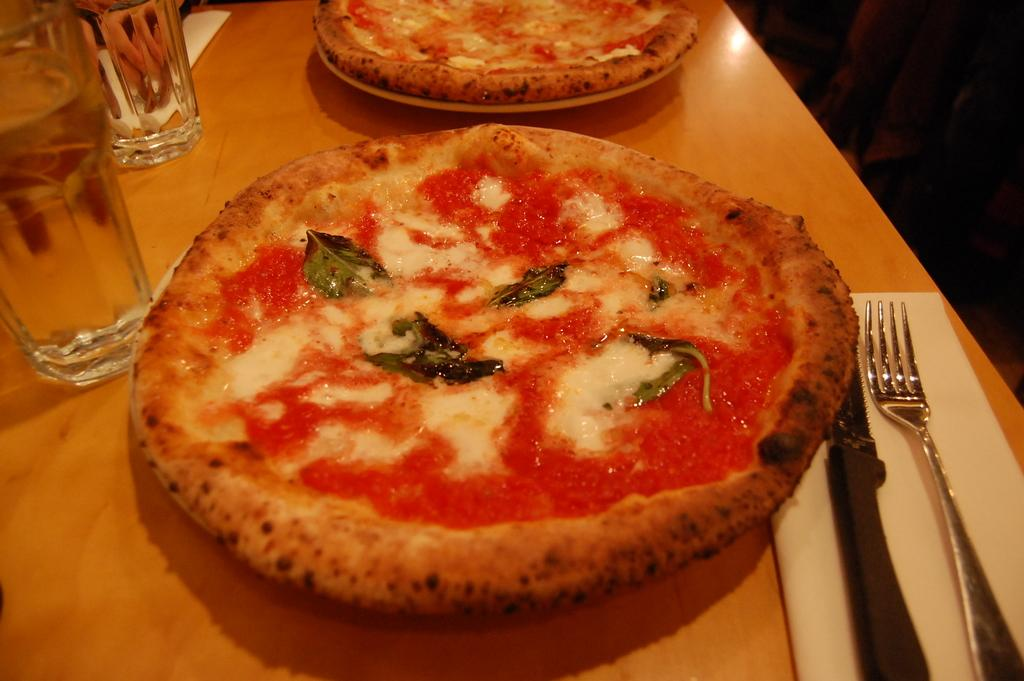What piece of furniture is present in the image? There is a table in the image. How many plates are on the table? There are two plates on the table. What can be used for cleaning or wiping on the table? There are tissue papers on the table. What utensils are on the table? There is a knife and a fork on the table. How many glasses are on the table? There are two glasses on the table. What type of food is on the plates? The plates contain pizzas. What type of knee can be seen on the table in the image? There is no knee present on the table in the image. What store is visible in the background of the image? There is no store visible in the image; it only shows a table with various items on it. 